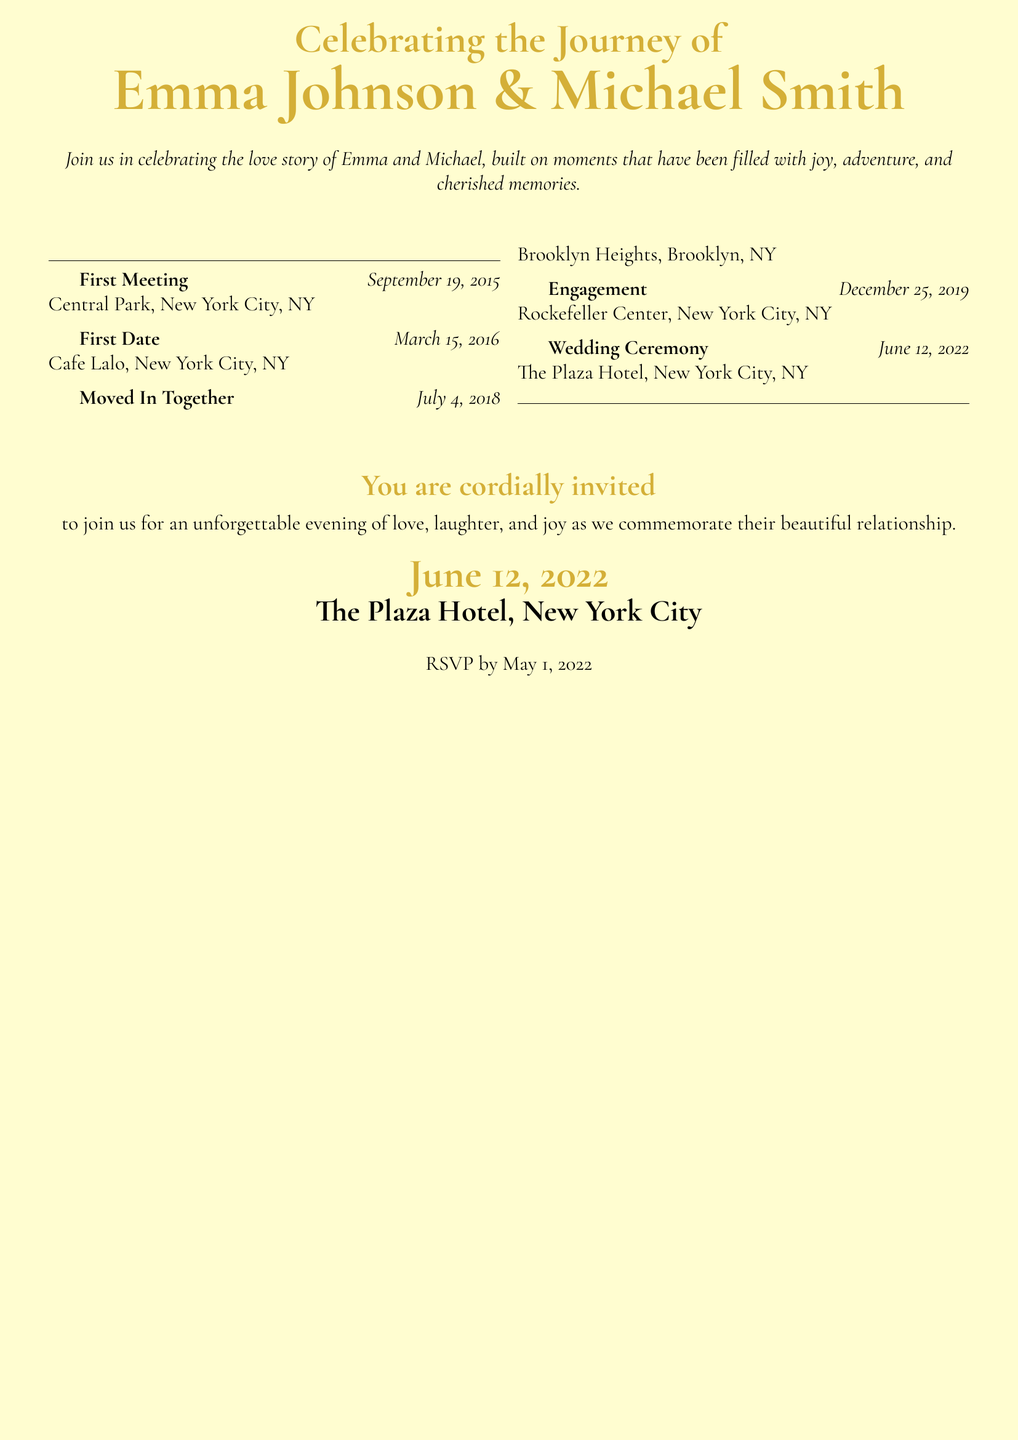what date did Emma and Michael first meet? The document states that Emma and Michael's first meeting took place on September 19, 2015.
Answer: September 19, 2015 where did they have their first date? The first date was at Cafe Lalo, which is mentioned in the document.
Answer: Cafe Lalo what is the date of their engagement? The engagement date is specifically listed in the timeline as December 25, 2019.
Answer: December 25, 2019 how many key milestones are mentioned in the document? The document outlines a total of five key milestones in Emma and Michael's relationship.
Answer: Five what type of event is being celebrated? The document is an invitation to celebrate the wedding ceremony of Emma and Michael.
Answer: Wedding Ceremony which location was chosen for the wedding ceremony? The document specifies The Plaza Hotel as the location for the wedding ceremony.
Answer: The Plaza Hotel when should guests RSVP by? The invitation states that guests should RSVP by May 1, 2022.
Answer: May 1, 2022 is there a specific theme emphasized in the invitation? The invitation emphasizes a theme of love, laughter, and joy, as noted in the description.
Answer: Love, laughter, and joy 